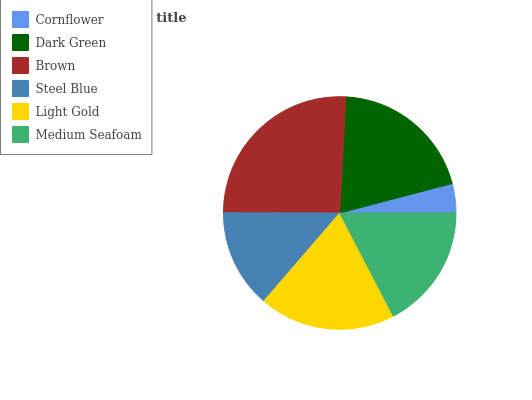Is Cornflower the minimum?
Answer yes or no. Yes. Is Brown the maximum?
Answer yes or no. Yes. Is Dark Green the minimum?
Answer yes or no. No. Is Dark Green the maximum?
Answer yes or no. No. Is Dark Green greater than Cornflower?
Answer yes or no. Yes. Is Cornflower less than Dark Green?
Answer yes or no. Yes. Is Cornflower greater than Dark Green?
Answer yes or no. No. Is Dark Green less than Cornflower?
Answer yes or no. No. Is Light Gold the high median?
Answer yes or no. Yes. Is Medium Seafoam the low median?
Answer yes or no. Yes. Is Dark Green the high median?
Answer yes or no. No. Is Light Gold the low median?
Answer yes or no. No. 